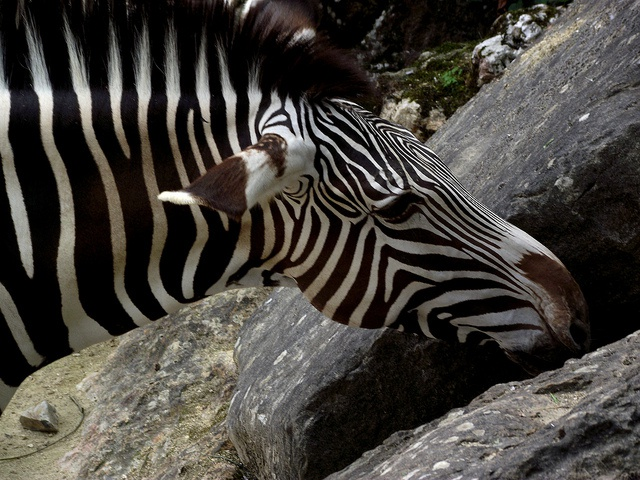Describe the objects in this image and their specific colors. I can see a zebra in black, gray, and darkgray tones in this image. 